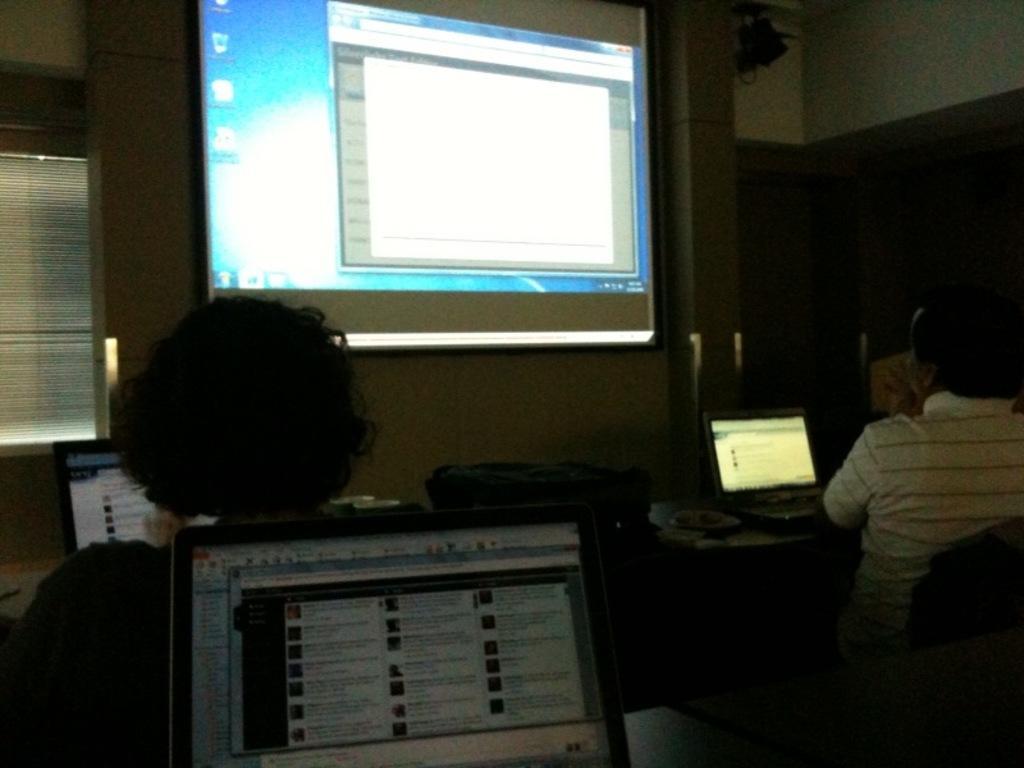Can you describe this image briefly? In a room there is a projector screen and something is being projected on that screen. In front of that some people are sitting on the seats and they are working with the laptops, behind the screen there is a wall and on the left side there is a window. 